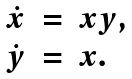Convert formula to latex. <formula><loc_0><loc_0><loc_500><loc_500>\begin{array} { r c l } \dot { x } & = & x y , \\ \dot { y } & = & x . \end{array}</formula> 